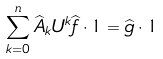Convert formula to latex. <formula><loc_0><loc_0><loc_500><loc_500>\sum _ { k = 0 } ^ { n } \widehat { A } _ { k } U ^ { k } \widehat { f } \cdot 1 = \widehat { g } \cdot 1</formula> 